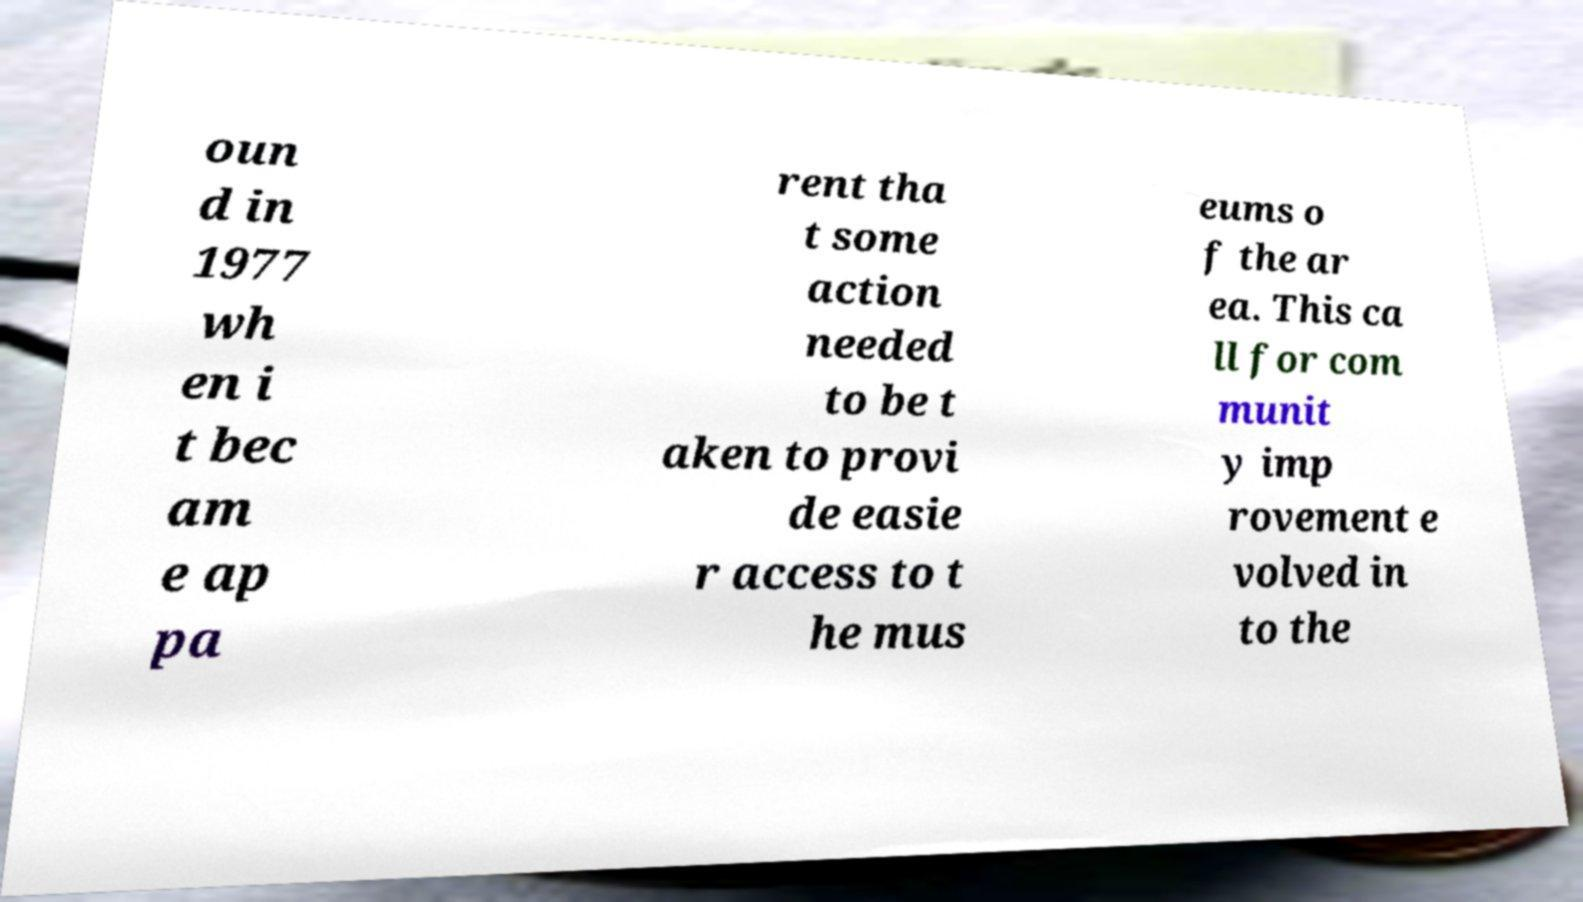Could you assist in decoding the text presented in this image and type it out clearly? oun d in 1977 wh en i t bec am e ap pa rent tha t some action needed to be t aken to provi de easie r access to t he mus eums o f the ar ea. This ca ll for com munit y imp rovement e volved in to the 